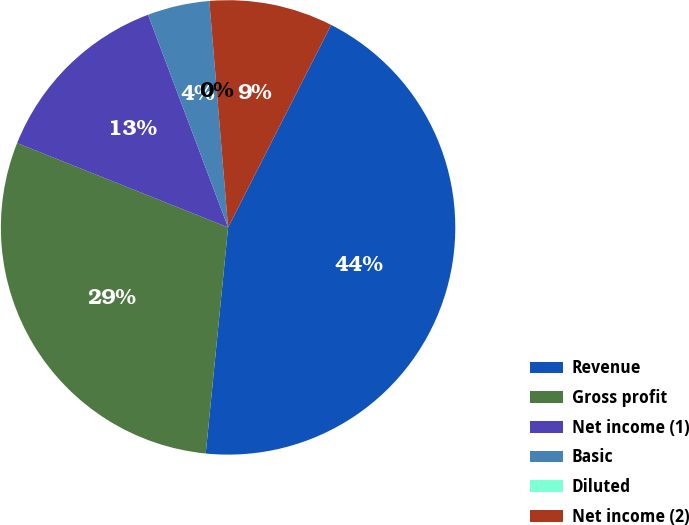Convert chart. <chart><loc_0><loc_0><loc_500><loc_500><pie_chart><fcel>Revenue<fcel>Gross profit<fcel>Net income (1)<fcel>Basic<fcel>Diluted<fcel>Net income (2)<nl><fcel>44.07%<fcel>29.48%<fcel>13.22%<fcel>4.41%<fcel>0.0%<fcel>8.81%<nl></chart> 